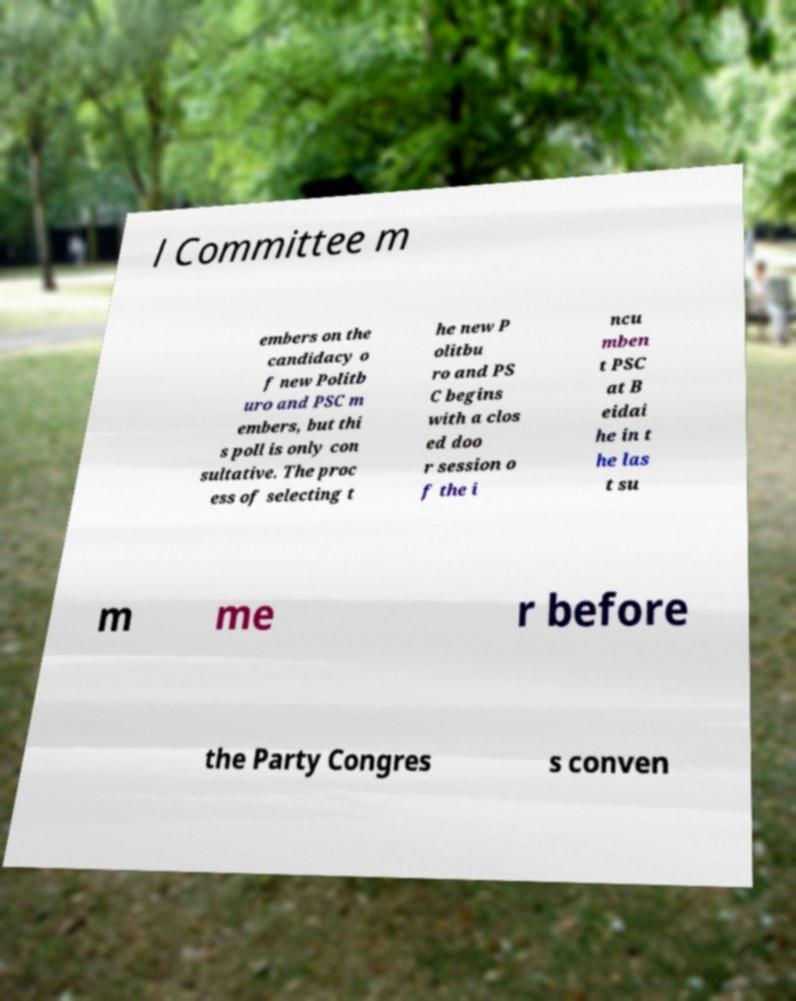Please identify and transcribe the text found in this image. l Committee m embers on the candidacy o f new Politb uro and PSC m embers, but thi s poll is only con sultative. The proc ess of selecting t he new P olitbu ro and PS C begins with a clos ed doo r session o f the i ncu mben t PSC at B eidai he in t he las t su m me r before the Party Congres s conven 